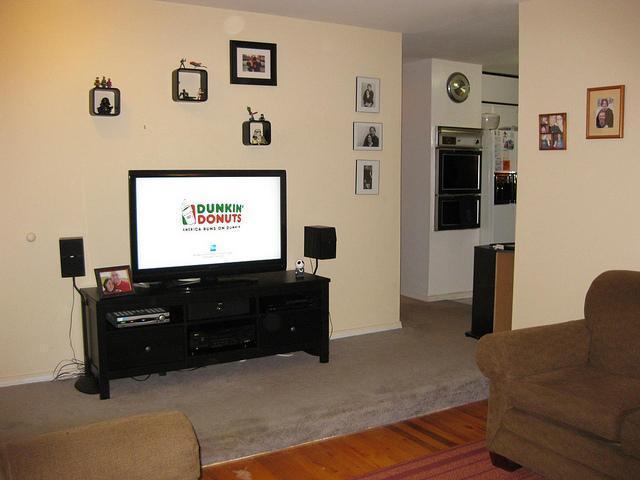How many couches are there?
Give a very brief answer. 2. How many chairs can you see?
Give a very brief answer. 2. 